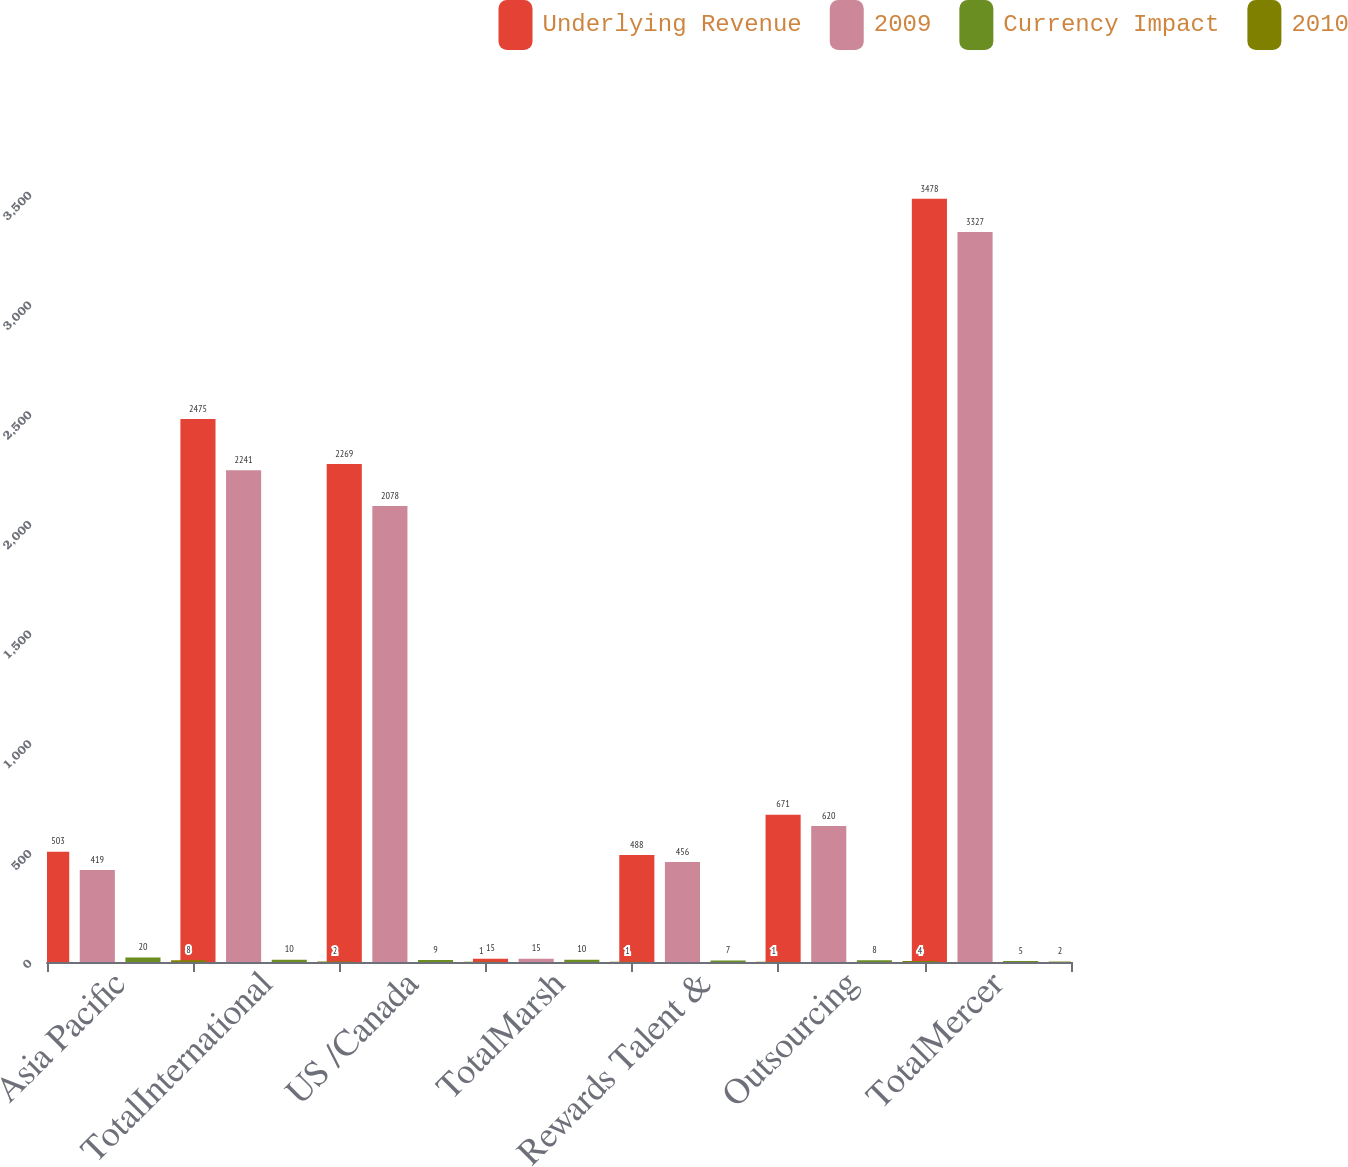Convert chart to OTSL. <chart><loc_0><loc_0><loc_500><loc_500><stacked_bar_chart><ecel><fcel>Asia Pacific<fcel>TotalInternational<fcel>US /Canada<fcel>TotalMarsh<fcel>Rewards Talent &<fcel>Outsourcing<fcel>TotalMercer<nl><fcel>Underlying Revenue<fcel>503<fcel>2475<fcel>2269<fcel>15<fcel>488<fcel>671<fcel>3478<nl><fcel>2009<fcel>419<fcel>2241<fcel>2078<fcel>15<fcel>456<fcel>620<fcel>3327<nl><fcel>Currency Impact<fcel>20<fcel>10<fcel>9<fcel>10<fcel>7<fcel>8<fcel>5<nl><fcel>2010<fcel>8<fcel>2<fcel>1<fcel>1<fcel>1<fcel>4<fcel>2<nl></chart> 